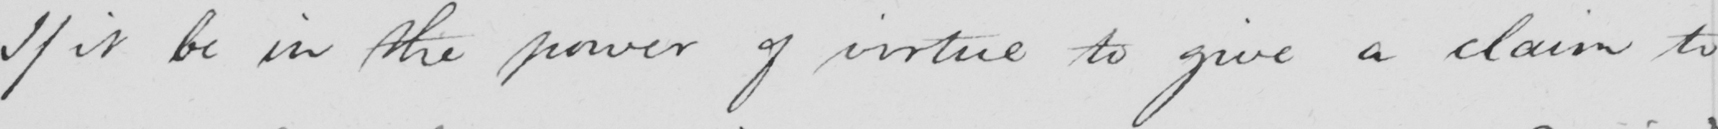Please transcribe the handwritten text in this image. If it be in the power of virtue to give a claim to 